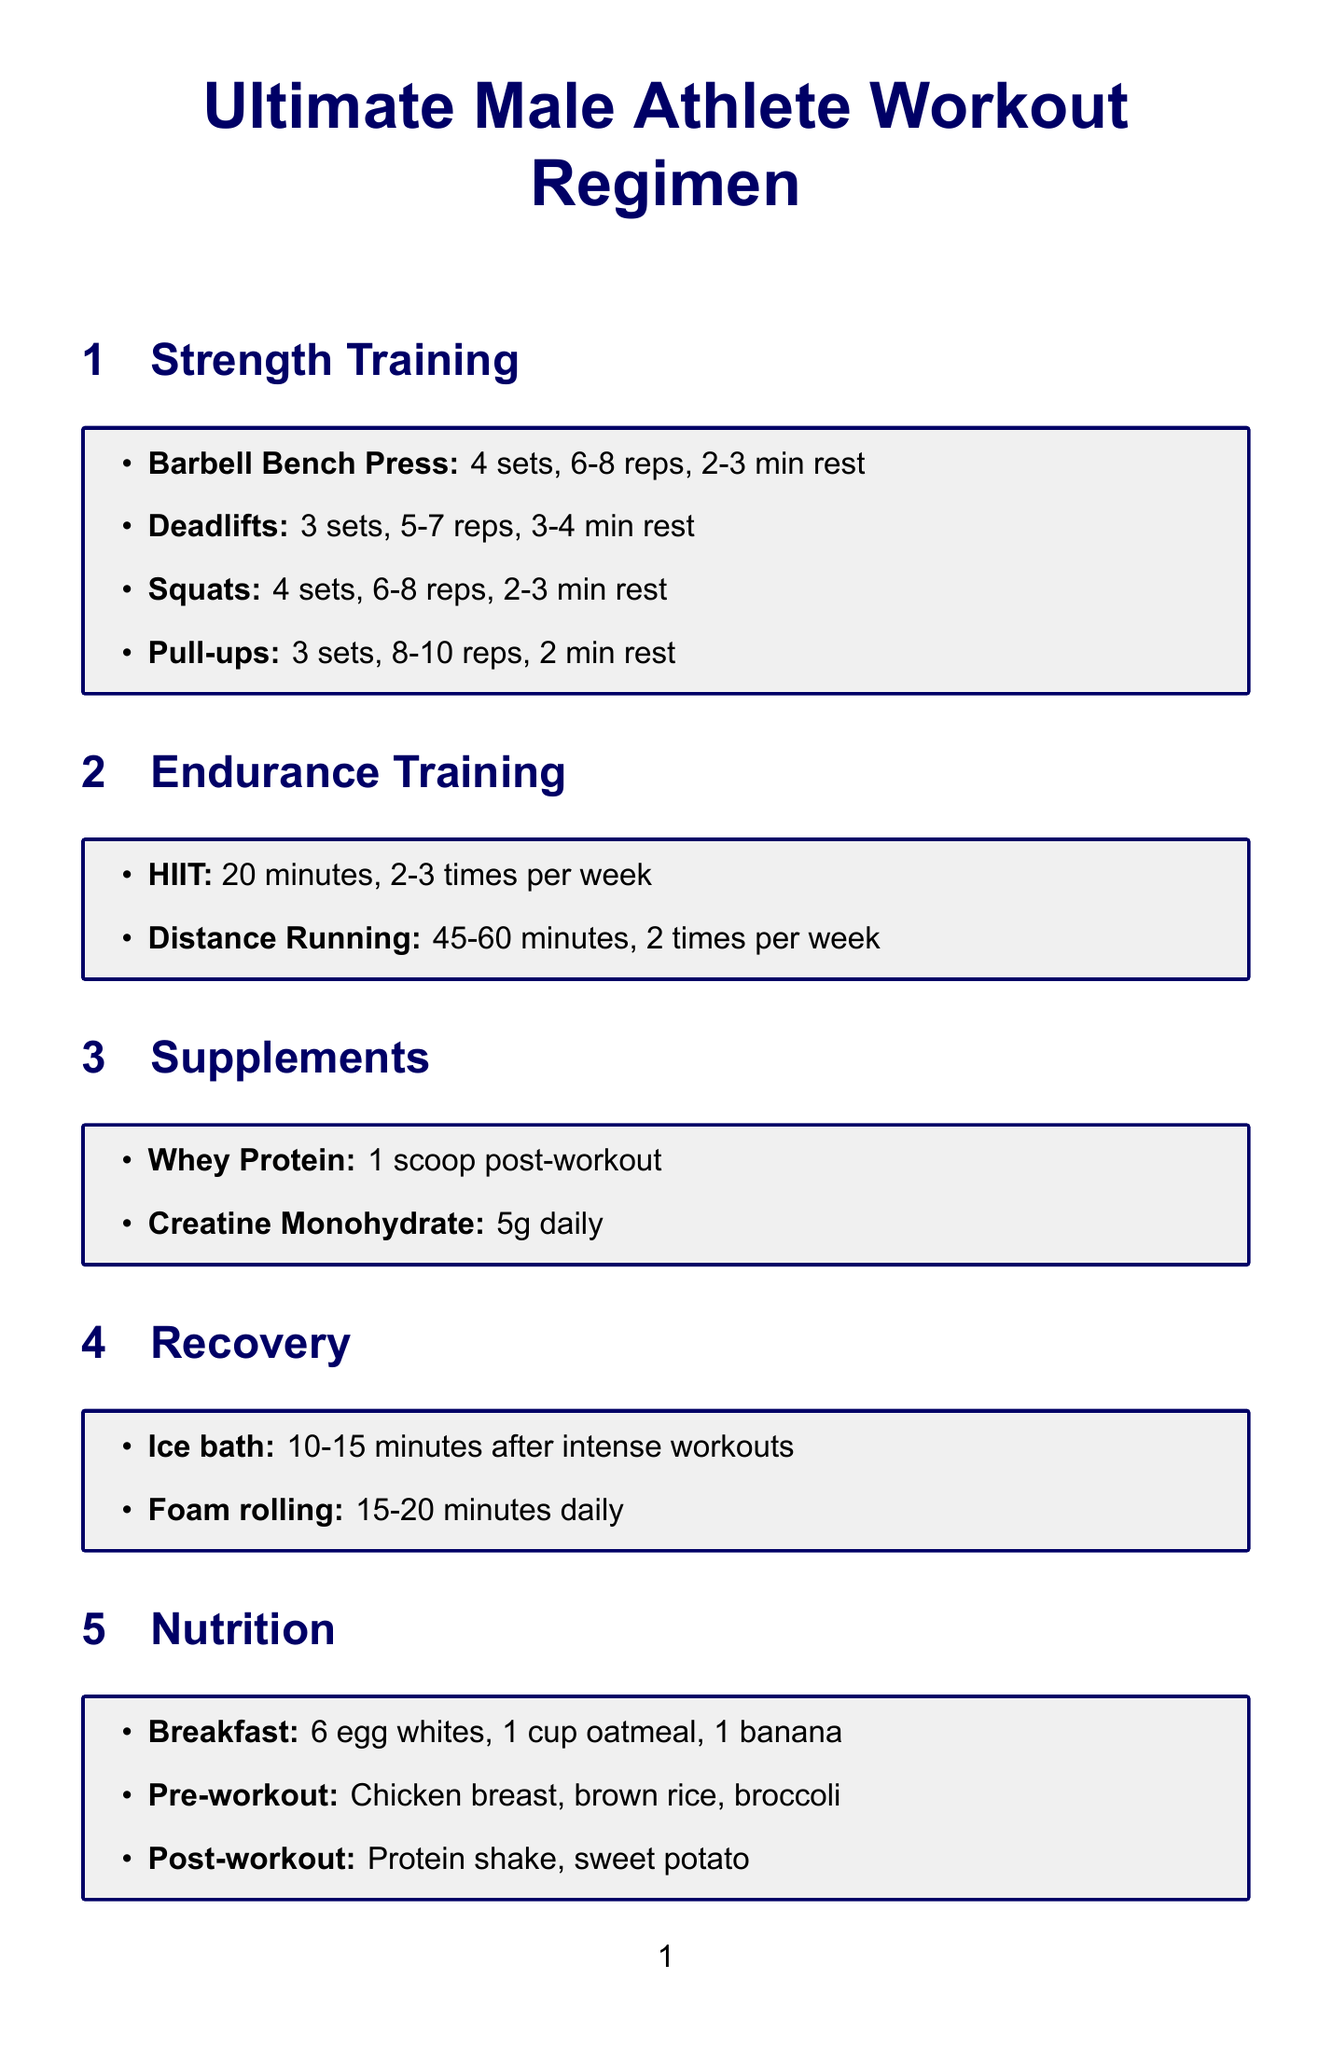What is the focus of the Barbell Bench Press? The focus of the Barbell Bench Press is to build upper body strength.
Answer: Upper body strength How many sets are recommended for Squats? The document states that 4 sets are recommended for Squats.
Answer: 4 sets What is the duration of the HIIT workout? The document specifies a duration of 20 minutes for the HIIT workout.
Answer: 20 minutes How often should Distance Running be performed? The document indicates that Distance Running should be done 2 times per week.
Answer: 2 times per week What supplement is suggested post-workout? The document recommends taking Whey Protein post-workout.
Answer: Whey Protein What method is suggested for recovery after intense workouts? The document suggests using an ice bath for recovery after intense workouts.
Answer: Ice bath What is one of the goals listed in the document? The document lists increasing bench press max by 10% in 3 months as one of the goals.
Answer: Increase bench press max by 10% in 3 months Which equipment is mentioned for the workout regimen? The document mentions the Olympic barbell set as part of the equipment.
Answer: Olympic barbell set What is the main mindset encouraged in the document? The document encourages focusing on personal growth and competition against oneself as a mindset.
Answer: Focus on personal growth and competition against oneself 